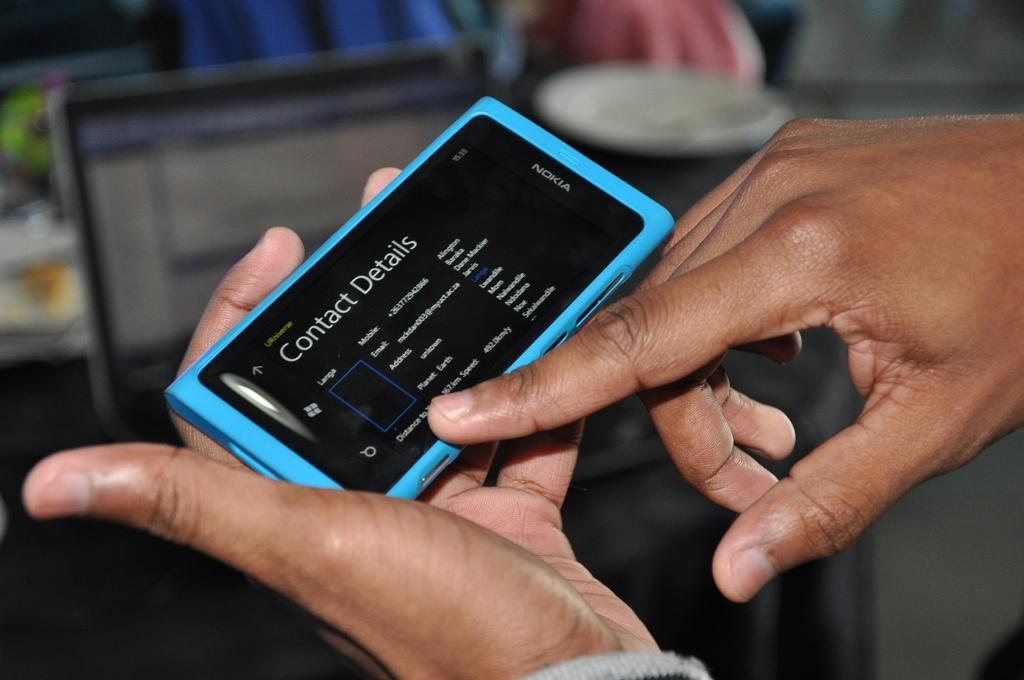Provide a one-sentence caption for the provided image. Nokia phone with the contact details screen open. 